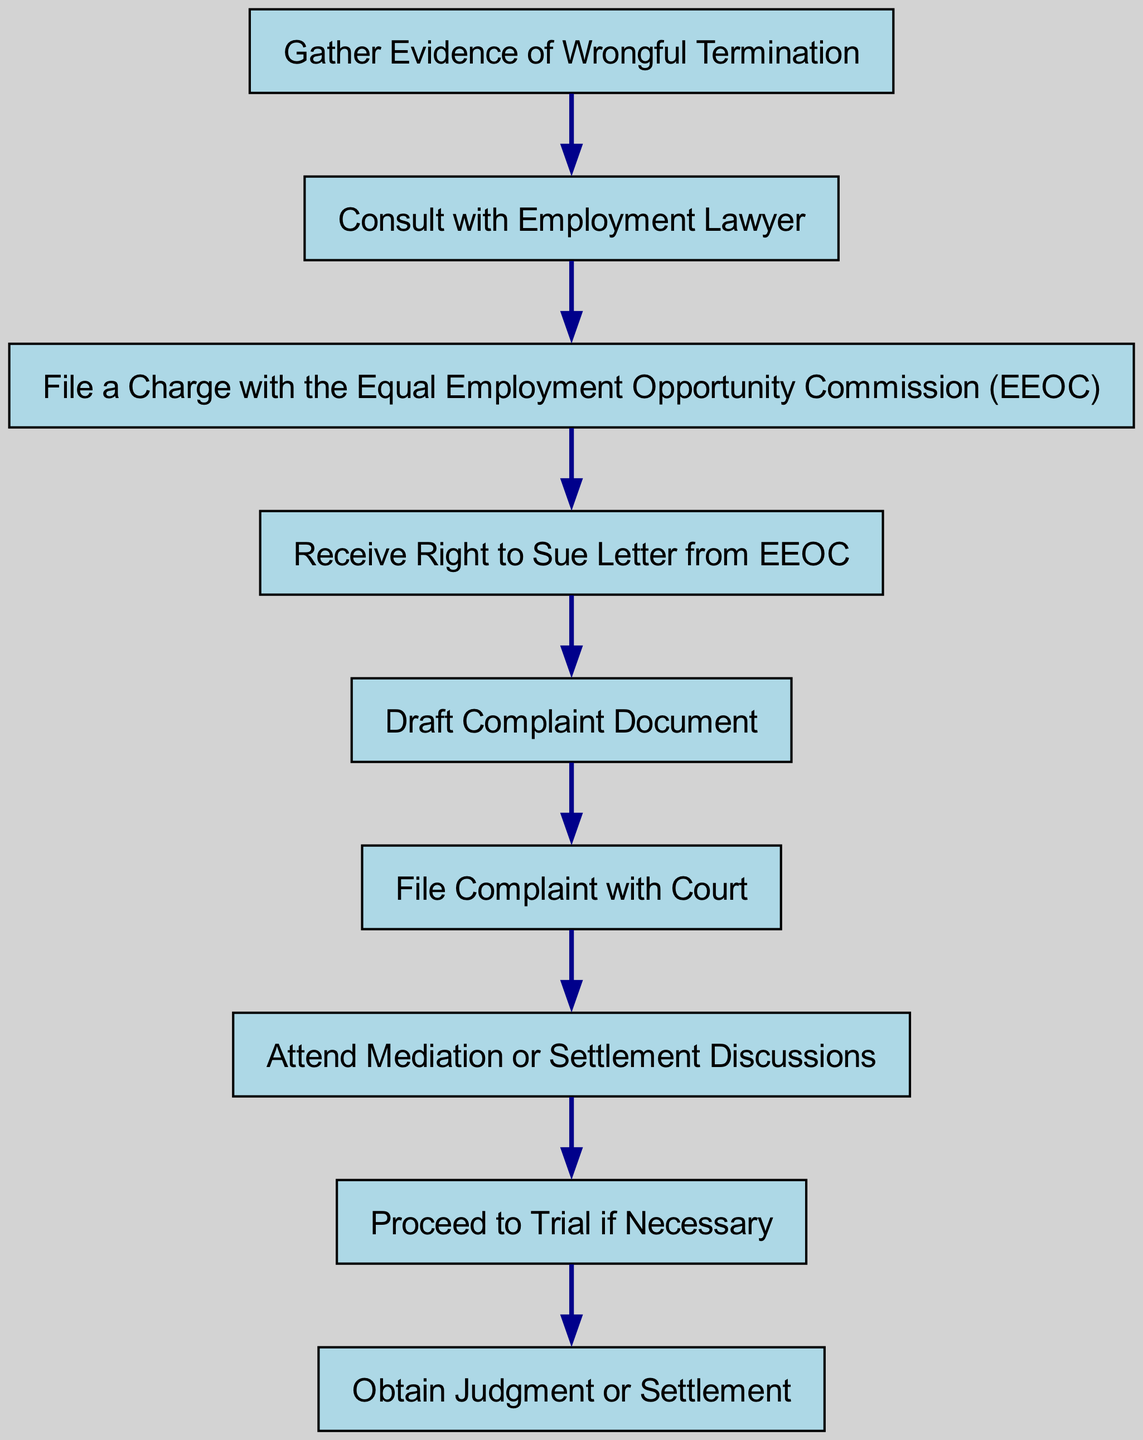What is the first step in the process? The first step in the directed graph is to "Gather Evidence of Wrongful Termination". This is indicated by the first node positioned at the top of the diagram.
Answer: Gather Evidence of Wrongful Termination How many steps are there in total? The total number of nodes is 9, representing the steps in the legal process. This can be counted directly from the list of nodes in the diagram.
Answer: 9 What follows after consulting with an employment lawyer? After "Consult with Employment Lawyer", the next step indicated in the diagram is to "File a Charge with the Equal Employment Opportunity Commission (EEOC)". This is the direct connection from one node to the next.
Answer: File a Charge with the Equal Employment Opportunity Commission (EEOC) What is the last step in the legal process? The final step in the directed graph is to "Obtain Judgment or Settlement". This node is the last one in the sequence of steps, indicating the conclusion of the lawsuit process.
Answer: Obtain Judgment or Settlement Is mediation required before proceeding to trial? Yes, "Attend Mediation or Settlement Discussions" is a prerequisite step before "Proceed to Trial if Necessary". This can be traced along the directed flow of the graph.
Answer: Yes What is the relationship between filing a complaint and attending mediation? The relationship is that after "File Complaint with Court", attending mediation or settlement discussions is the next step. This indicates that filing a complaint leads to mediation.
Answer: Attend Mediation or Settlement Discussions How many edges are present in the diagram? There are 8 edges connecting the nodes in this directed graph. Each directed connection from one step to the next represents an edge, which are listed in the edges data.
Answer: 8 If mediation is unsuccessful, what is the next action? If mediation doesn't result in a settlement, the next action is to "Proceed to Trial if Necessary". This follows the directed path depicted in the diagram from mediation to trial.
Answer: Proceed to Trial if Necessary What type of document must be drafted after receiving the Right to Sue letter? The document that must be drafted is the "Complaint Document", as indicated in the sequence following the receipt of the Right to Sue letter.
Answer: Draft Complaint Document 